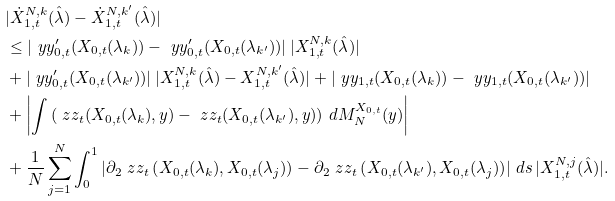<formula> <loc_0><loc_0><loc_500><loc_500>& | \dot { X } _ { 1 , t } ^ { N , k } ( \hat { \lambda } ) - \dot { X } _ { 1 , t } ^ { N , k ^ { \prime } } ( \hat { \lambda } ) | \\ & \leq | \ y y _ { 0 , t } ^ { \prime } ( X _ { 0 , t } ( \lambda _ { k } ) ) - \ y y _ { 0 , t } ^ { \prime } ( X _ { 0 , t } ( \lambda _ { k ^ { \prime } } ) ) | \, | X _ { 1 , t } ^ { N , k } ( \hat { \lambda } ) | \\ & + | \ y y _ { 0 , t } ^ { \prime } ( X _ { 0 , t } ( \lambda _ { k ^ { \prime } } ) ) | \, | X _ { 1 , t } ^ { N , k } ( \hat { \lambda } ) - X _ { 1 , t } ^ { N , k ^ { \prime } } ( \hat { \lambda } ) | + | \ y y _ { 1 , t } ( X _ { 0 , t } ( \lambda _ { k } ) ) - \ y y _ { 1 , t } ( X _ { 0 , t } ( \lambda _ { k ^ { \prime } } ) ) | \\ & + \left | \int \left ( \ z z _ { t } ( X _ { 0 , t } ( \lambda _ { k } ) , y ) - \ z z _ { t } ( X _ { 0 , t } ( \lambda _ { k ^ { \prime } } ) , y ) \right ) \, d M _ { N } ^ { X _ { 0 , t } } ( y ) \right | \\ & + \frac { 1 } { N } \sum _ { j = 1 } ^ { N } \int _ { 0 } ^ { 1 } \left | \partial _ { 2 } \ z z _ { t } \left ( X _ { 0 , t } ( \lambda _ { k } ) , X _ { 0 , t } ( \lambda _ { j } ) \right ) - \partial _ { 2 } \ z z _ { t } \left ( X _ { 0 , t } ( \lambda _ { k ^ { \prime } } ) , X _ { 0 , t } ( \lambda _ { j } ) \right ) \right | \, d s \, | X _ { 1 , t } ^ { N , j } ( \hat { \lambda } ) | .</formula> 